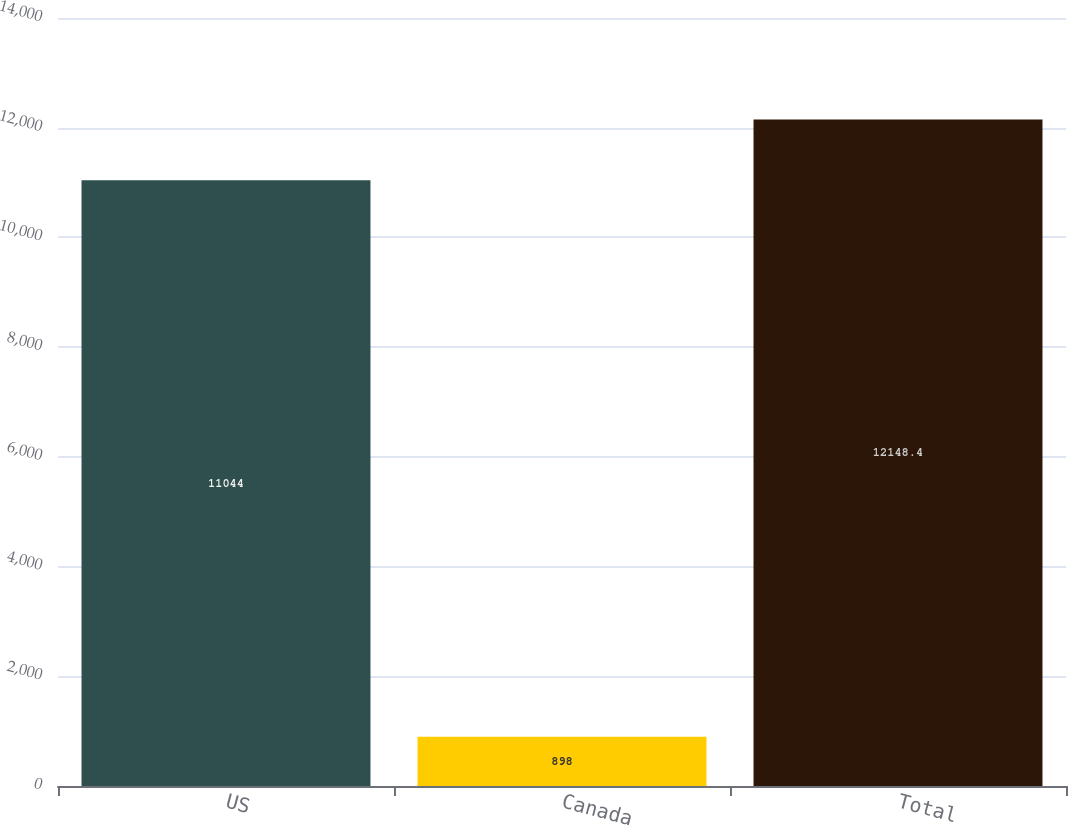Convert chart. <chart><loc_0><loc_0><loc_500><loc_500><bar_chart><fcel>US<fcel>Canada<fcel>Total<nl><fcel>11044<fcel>898<fcel>12148.4<nl></chart> 